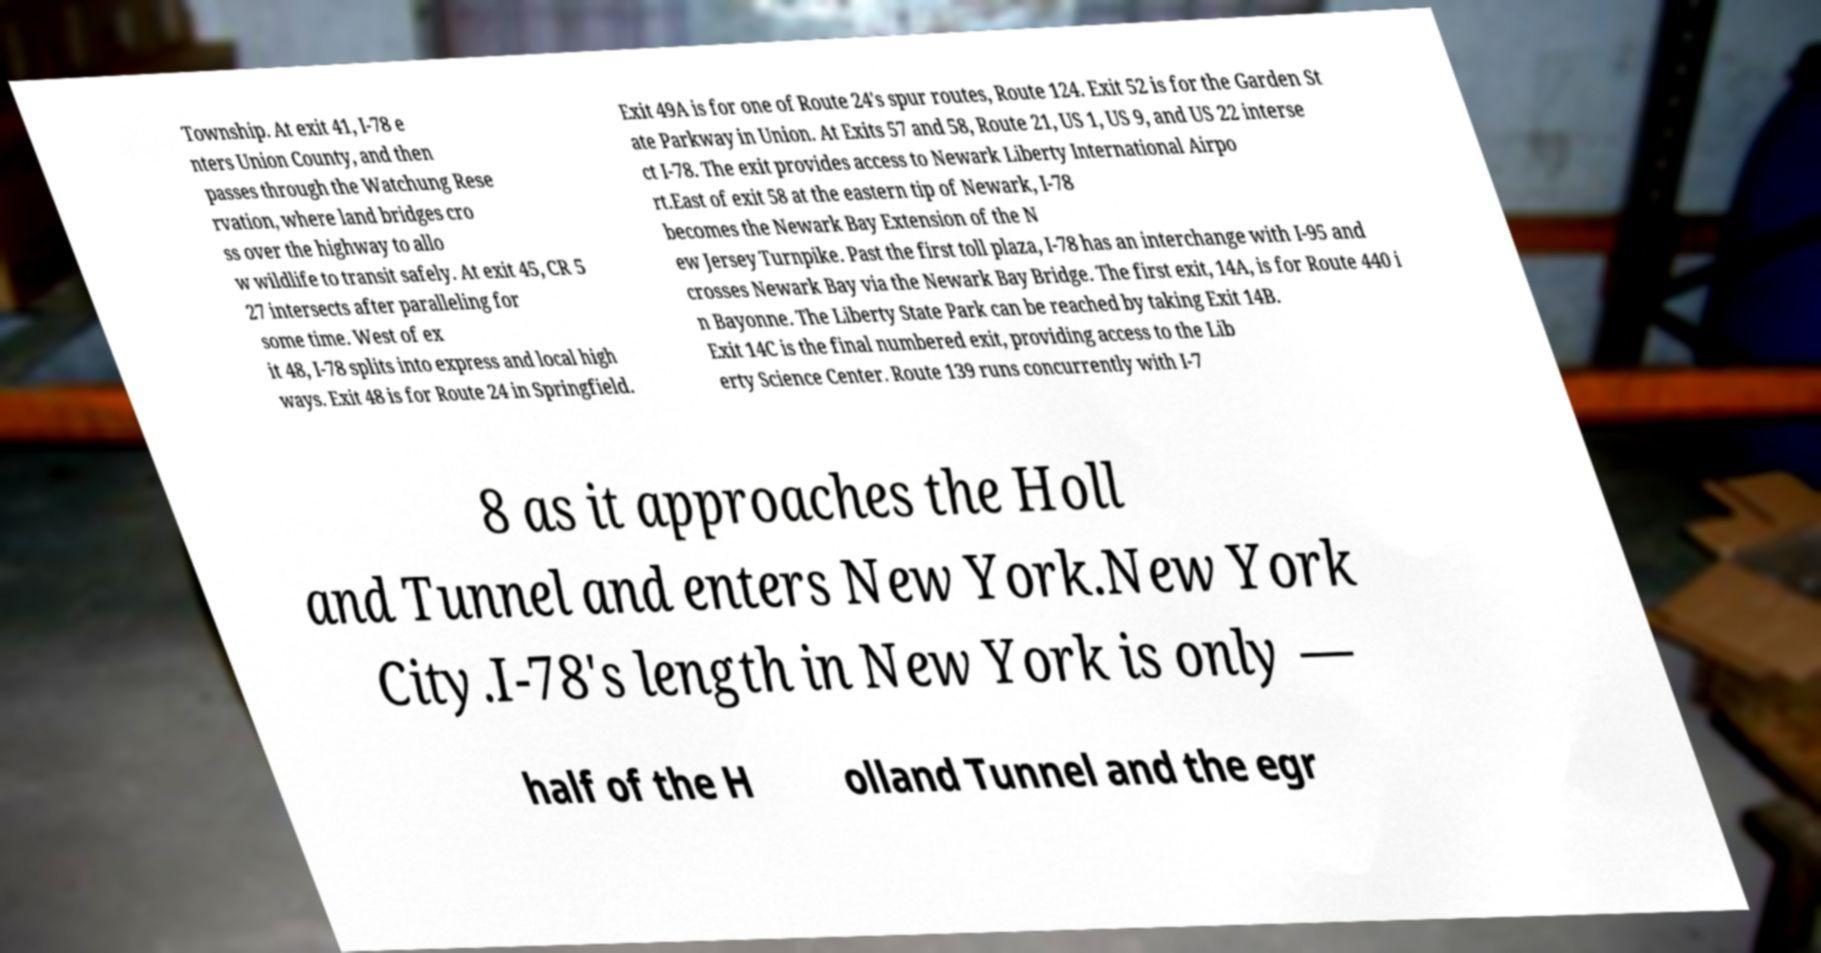Could you assist in decoding the text presented in this image and type it out clearly? Township. At exit 41, I-78 e nters Union County, and then passes through the Watchung Rese rvation, where land bridges cro ss over the highway to allo w wildlife to transit safely. At exit 45, CR 5 27 intersects after paralleling for some time. West of ex it 48, I-78 splits into express and local high ways. Exit 48 is for Route 24 in Springfield. Exit 49A is for one of Route 24's spur routes, Route 124. Exit 52 is for the Garden St ate Parkway in Union. At Exits 57 and 58, Route 21, US 1, US 9, and US 22 interse ct I-78. The exit provides access to Newark Liberty International Airpo rt.East of exit 58 at the eastern tip of Newark, I-78 becomes the Newark Bay Extension of the N ew Jersey Turnpike. Past the first toll plaza, I-78 has an interchange with I-95 and crosses Newark Bay via the Newark Bay Bridge. The first exit, 14A, is for Route 440 i n Bayonne. The Liberty State Park can be reached by taking Exit 14B. Exit 14C is the final numbered exit, providing access to the Lib erty Science Center. Route 139 runs concurrently with I-7 8 as it approaches the Holl and Tunnel and enters New York.New York City.I-78's length in New York is only — half of the H olland Tunnel and the egr 